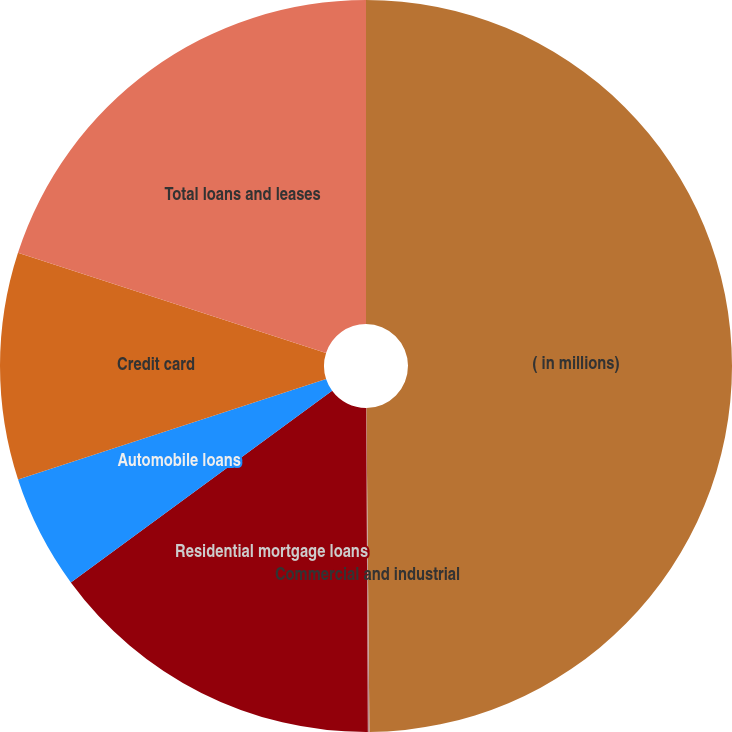<chart> <loc_0><loc_0><loc_500><loc_500><pie_chart><fcel>( in millions)<fcel>Commercial and industrial<fcel>Residential mortgage loans<fcel>Automobile loans<fcel>Credit card<fcel>Total loans and leases<nl><fcel>49.85%<fcel>0.07%<fcel>15.01%<fcel>5.05%<fcel>10.03%<fcel>19.99%<nl></chart> 